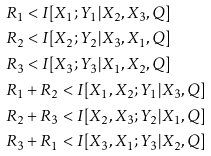<formula> <loc_0><loc_0><loc_500><loc_500>& R _ { 1 } < I [ X _ { 1 } ; Y _ { 1 } | X _ { 2 } , X _ { 3 } , Q ] \\ & R _ { 2 } < I [ X _ { 2 } ; Y _ { 2 } | X _ { 3 } , X _ { 1 } , Q ] \\ & R _ { 3 } < I [ X _ { 3 } ; Y _ { 3 } | X _ { 1 } , X _ { 2 } , Q ] \\ & R _ { 1 } + R _ { 2 } < I [ X _ { 1 } , X _ { 2 } ; Y _ { 1 } | X _ { 3 } , Q ] \\ & R _ { 2 } + R _ { 3 } < I [ X _ { 2 } , X _ { 3 } ; Y _ { 2 } | X _ { 1 } , Q ] \\ & R _ { 3 } + R _ { 1 } < I [ X _ { 3 } , X _ { 1 } ; Y _ { 3 } | X _ { 2 } , Q ]</formula> 